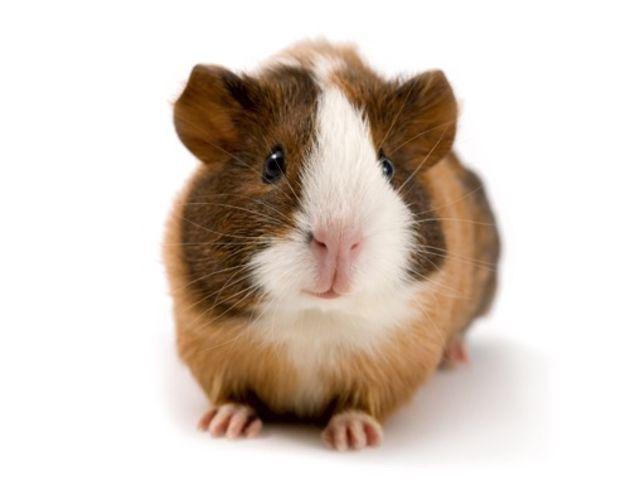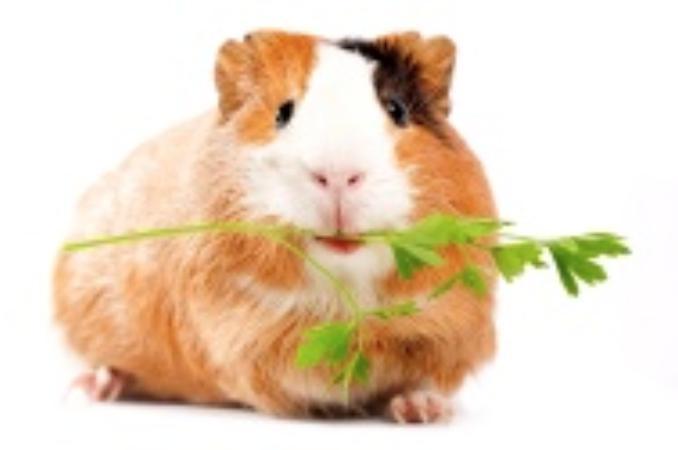The first image is the image on the left, the second image is the image on the right. For the images displayed, is the sentence "There are two hamsters in total." factually correct? Answer yes or no. Yes. 